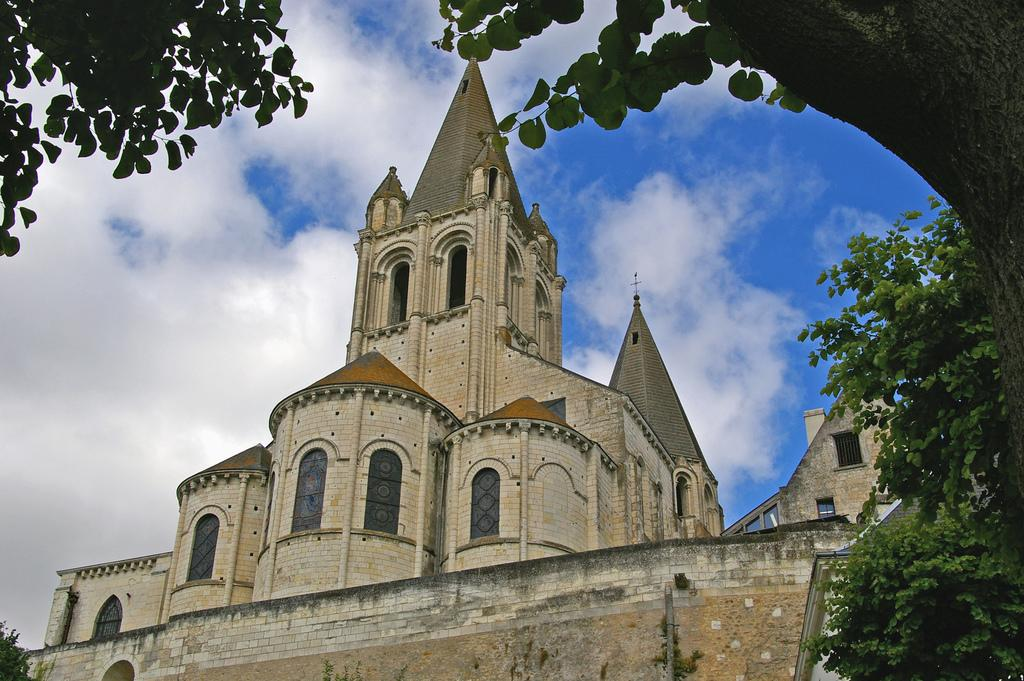What type of structure is present in the image? There is a building in the image. What feature can be seen on the building? There are windows visible in the image. What type of vegetation is present in the image? There are trees in the image. What is visible at the top of the image? The sky is visible at the top of the image. Reasoning: Let'ing: Let's think step by step in order to produce the conversation. We start by identifying the main subject in the image, which is the building. Then, we expand the conversation to include other details about the building, such as the presence of windows. Next, we mention the trees and the sky, which are also visible in the image. Each question is designed to elicit a specific detail about the image that is known from the provided facts. Absurd Question/Answer: What color is the orange hanging from the copper wire in the image? There is no orange or copper wire present in the image. 